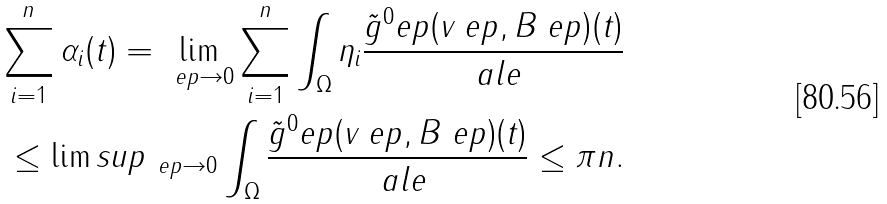<formula> <loc_0><loc_0><loc_500><loc_500>\sum _ { i = 1 } ^ { n } \alpha _ { i } ( t ) = \lim _ { \ e p \rightarrow 0 } \sum _ { i = 1 } ^ { n } \int _ { \Omega } \eta _ { i } \frac { \tilde { g } ^ { 0 } _ { \ } e p ( v _ { \ } e p , B _ { \ } e p ) ( t ) } { \ a l e } \\ \leq \lim s u p _ { \ e p \rightarrow 0 } \int _ { \Omega } \frac { \tilde { g } ^ { 0 } _ { \ } e p ( v _ { \ } e p , B _ { \ } e p ) ( t ) } { \ a l e } \leq \pi n .</formula> 